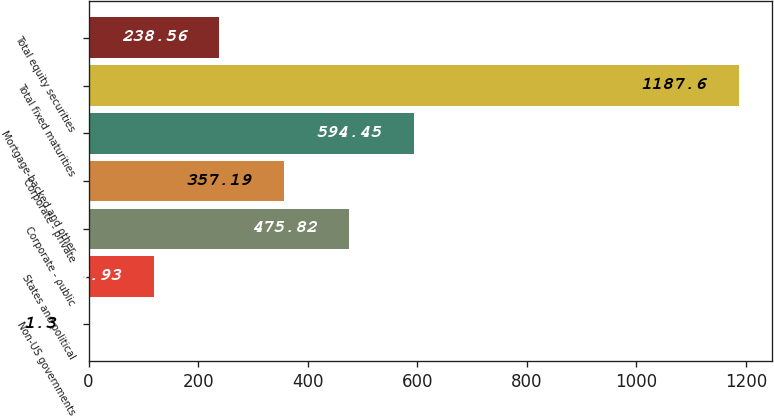Convert chart to OTSL. <chart><loc_0><loc_0><loc_500><loc_500><bar_chart><fcel>Non-US governments<fcel>States and political<fcel>Corporate - public<fcel>Corporate - private<fcel>Mortgage-backed and other<fcel>Total fixed maturities<fcel>Total equity securities<nl><fcel>1.3<fcel>119.93<fcel>475.82<fcel>357.19<fcel>594.45<fcel>1187.6<fcel>238.56<nl></chart> 